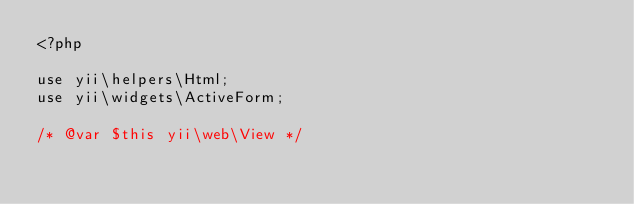<code> <loc_0><loc_0><loc_500><loc_500><_PHP_><?php

use yii\helpers\Html;
use yii\widgets\ActiveForm;

/* @var $this yii\web\View */</code> 